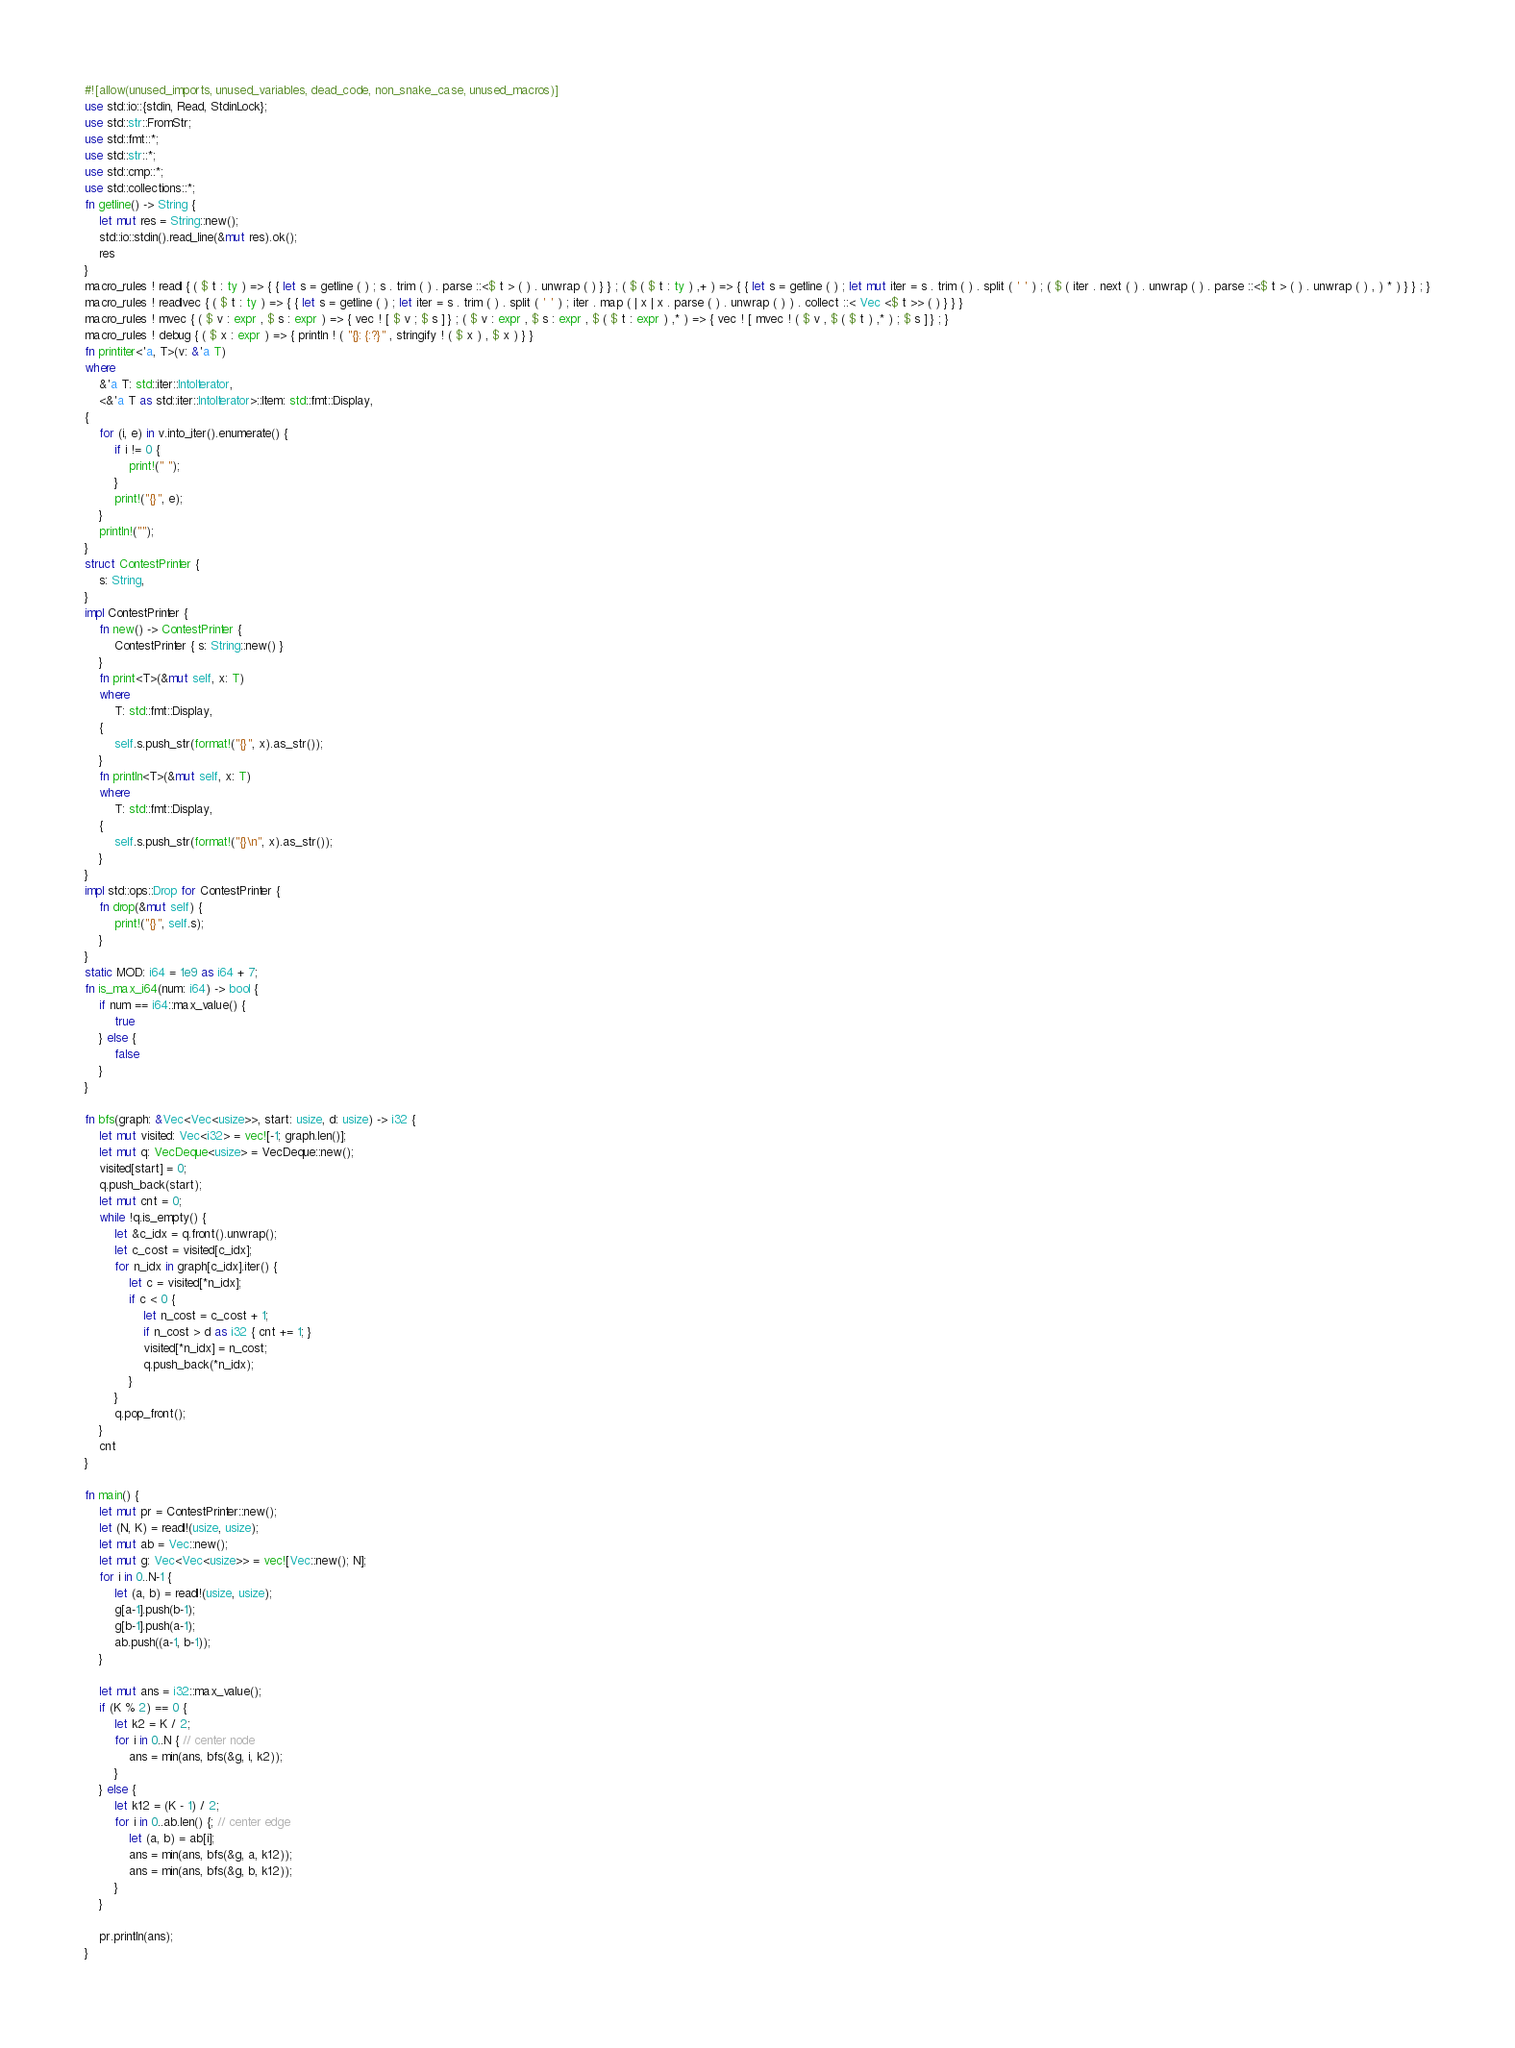<code> <loc_0><loc_0><loc_500><loc_500><_Rust_>#![allow(unused_imports, unused_variables, dead_code, non_snake_case, unused_macros)]
use std::io::{stdin, Read, StdinLock};
use std::str::FromStr;
use std::fmt::*;
use std::str::*;
use std::cmp::*;
use std::collections::*;
fn getline() -> String {
    let mut res = String::new();
    std::io::stdin().read_line(&mut res).ok();
    res
}
macro_rules ! readl { ( $ t : ty ) => { { let s = getline ( ) ; s . trim ( ) . parse ::<$ t > ( ) . unwrap ( ) } } ; ( $ ( $ t : ty ) ,+ ) => { { let s = getline ( ) ; let mut iter = s . trim ( ) . split ( ' ' ) ; ( $ ( iter . next ( ) . unwrap ( ) . parse ::<$ t > ( ) . unwrap ( ) , ) * ) } } ; }
macro_rules ! readlvec { ( $ t : ty ) => { { let s = getline ( ) ; let iter = s . trim ( ) . split ( ' ' ) ; iter . map ( | x | x . parse ( ) . unwrap ( ) ) . collect ::< Vec <$ t >> ( ) } } }
macro_rules ! mvec { ( $ v : expr , $ s : expr ) => { vec ! [ $ v ; $ s ] } ; ( $ v : expr , $ s : expr , $ ( $ t : expr ) ,* ) => { vec ! [ mvec ! ( $ v , $ ( $ t ) ,* ) ; $ s ] } ; }
macro_rules ! debug { ( $ x : expr ) => { println ! ( "{}: {:?}" , stringify ! ( $ x ) , $ x ) } }
fn printiter<'a, T>(v: &'a T)
where
    &'a T: std::iter::IntoIterator,
    <&'a T as std::iter::IntoIterator>::Item: std::fmt::Display,
{
    for (i, e) in v.into_iter().enumerate() {
        if i != 0 {
            print!(" ");
        }
        print!("{}", e);
    }
    println!("");
}
struct ContestPrinter {
    s: String,
}
impl ContestPrinter {
    fn new() -> ContestPrinter {
        ContestPrinter { s: String::new() }
    }
    fn print<T>(&mut self, x: T)
    where
        T: std::fmt::Display,
    {
        self.s.push_str(format!("{}", x).as_str());
    }
    fn println<T>(&mut self, x: T)
    where
        T: std::fmt::Display,
    {
        self.s.push_str(format!("{}\n", x).as_str());
    }
}
impl std::ops::Drop for ContestPrinter {
    fn drop(&mut self) {
        print!("{}", self.s);
    }
}
static MOD: i64 = 1e9 as i64 + 7;
fn is_max_i64(num: i64) -> bool {
    if num == i64::max_value() {
        true
    } else {
        false
    }
}

fn bfs(graph: &Vec<Vec<usize>>, start: usize, d: usize) -> i32 {
    let mut visited: Vec<i32> = vec![-1; graph.len()];
    let mut q: VecDeque<usize> = VecDeque::new();
    visited[start] = 0;
    q.push_back(start);
    let mut cnt = 0;
    while !q.is_empty() {
        let &c_idx = q.front().unwrap();
        let c_cost = visited[c_idx];
        for n_idx in graph[c_idx].iter() {
            let c = visited[*n_idx];
            if c < 0 {
                let n_cost = c_cost + 1;
                if n_cost > d as i32 { cnt += 1; }
                visited[*n_idx] = n_cost;
                q.push_back(*n_idx);
            }
        }
        q.pop_front();
    }
    cnt
}

fn main() {
    let mut pr = ContestPrinter::new();
    let (N, K) = readl!(usize, usize);
    let mut ab = Vec::new();
    let mut g: Vec<Vec<usize>> = vec![Vec::new(); N];
    for i in 0..N-1 {
        let (a, b) = readl!(usize, usize);
        g[a-1].push(b-1);
        g[b-1].push(a-1);
        ab.push((a-1, b-1));
    }

    let mut ans = i32::max_value();
    if (K % 2) == 0 {
        let k2 = K / 2;
        for i in 0..N { // center node
            ans = min(ans, bfs(&g, i, k2));
        }
    } else {
        let k12 = (K - 1) / 2;
        for i in 0..ab.len() {; // center edge
            let (a, b) = ab[i];
            ans = min(ans, bfs(&g, a, k12));
            ans = min(ans, bfs(&g, b, k12));
        }
    }

    pr.println(ans);
}</code> 